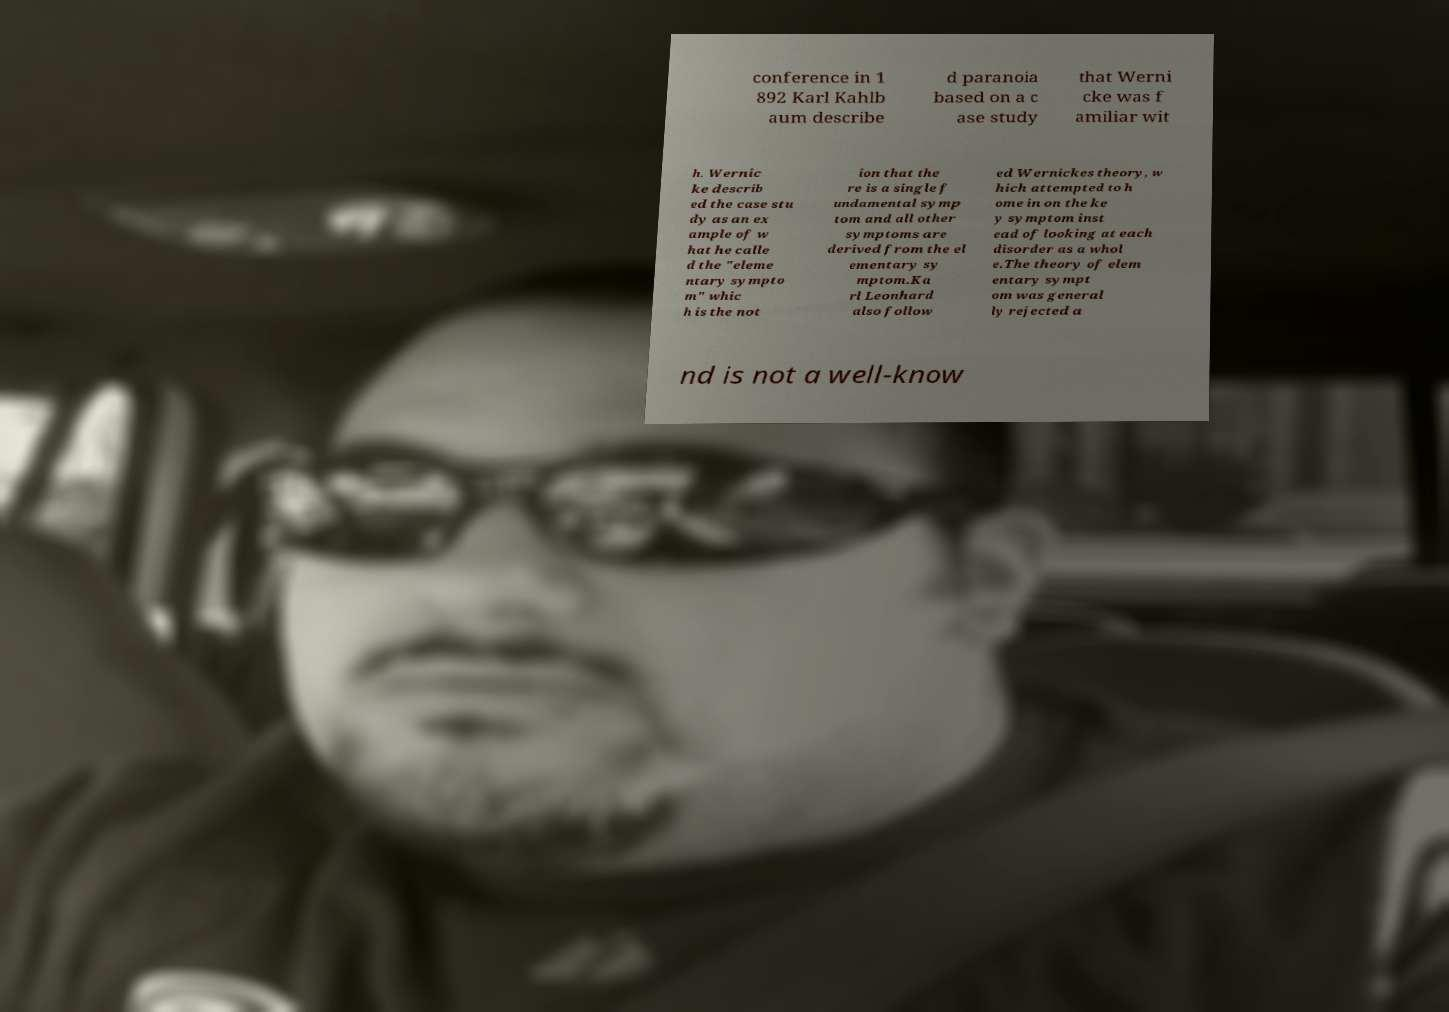Please identify and transcribe the text found in this image. conference in 1 892 Karl Kahlb aum describe d paranoia based on a c ase study that Werni cke was f amiliar wit h. Wernic ke describ ed the case stu dy as an ex ample of w hat he calle d the "eleme ntary sympto m" whic h is the not ion that the re is a single f undamental symp tom and all other symptoms are derived from the el ementary sy mptom.Ka rl Leonhard also follow ed Wernickes theory, w hich attempted to h ome in on the ke y symptom inst ead of looking at each disorder as a whol e.The theory of elem entary sympt om was general ly rejected a nd is not a well-know 